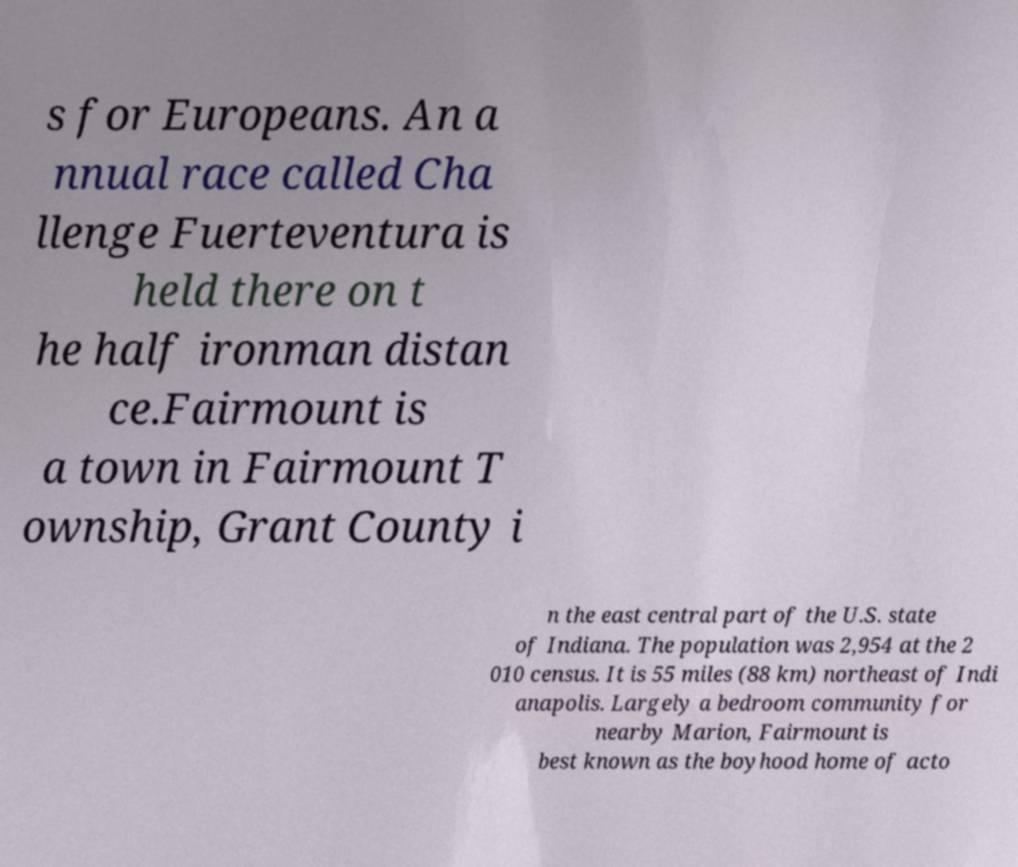Could you assist in decoding the text presented in this image and type it out clearly? s for Europeans. An a nnual race called Cha llenge Fuerteventura is held there on t he half ironman distan ce.Fairmount is a town in Fairmount T ownship, Grant County i n the east central part of the U.S. state of Indiana. The population was 2,954 at the 2 010 census. It is 55 miles (88 km) northeast of Indi anapolis. Largely a bedroom community for nearby Marion, Fairmount is best known as the boyhood home of acto 